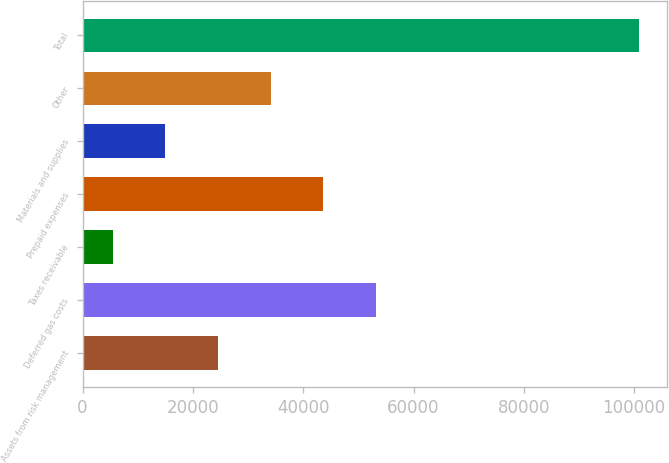Convert chart to OTSL. <chart><loc_0><loc_0><loc_500><loc_500><bar_chart><fcel>Assets from risk management<fcel>Deferred gas costs<fcel>Taxes receivable<fcel>Prepaid expenses<fcel>Materials and supplies<fcel>Other<fcel>Total<nl><fcel>24530.6<fcel>53142.5<fcel>5456<fcel>43605.2<fcel>14993.3<fcel>34067.9<fcel>100829<nl></chart> 